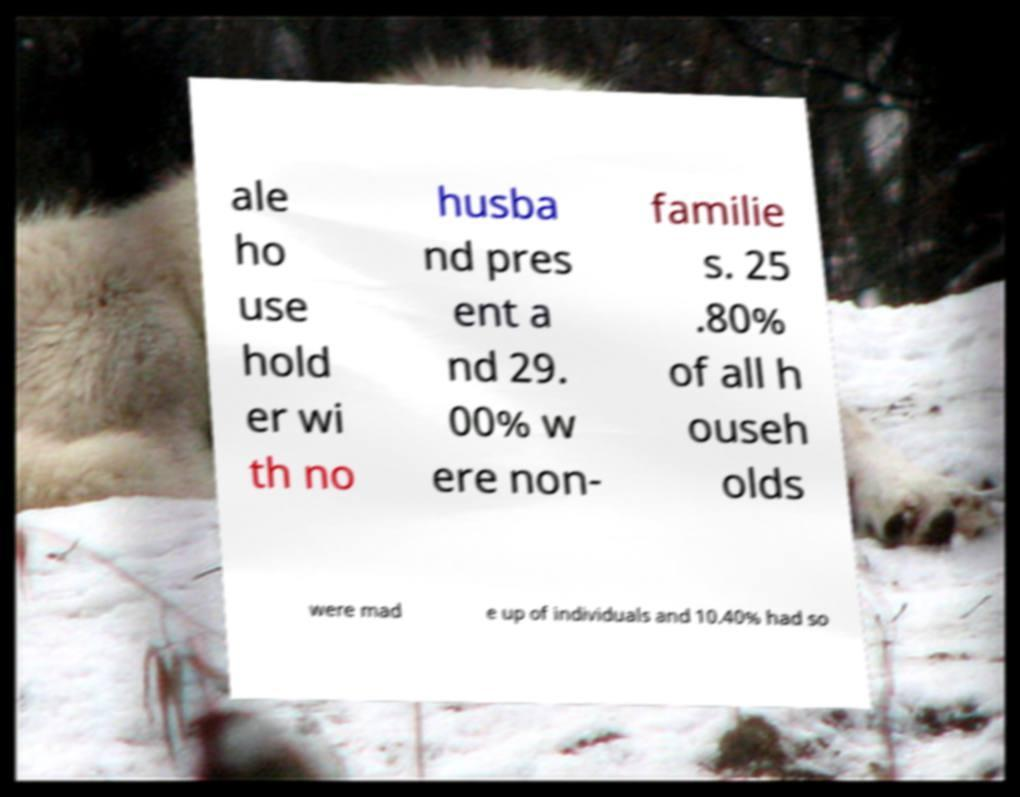Can you accurately transcribe the text from the provided image for me? ale ho use hold er wi th no husba nd pres ent a nd 29. 00% w ere non- familie s. 25 .80% of all h ouseh olds were mad e up of individuals and 10.40% had so 